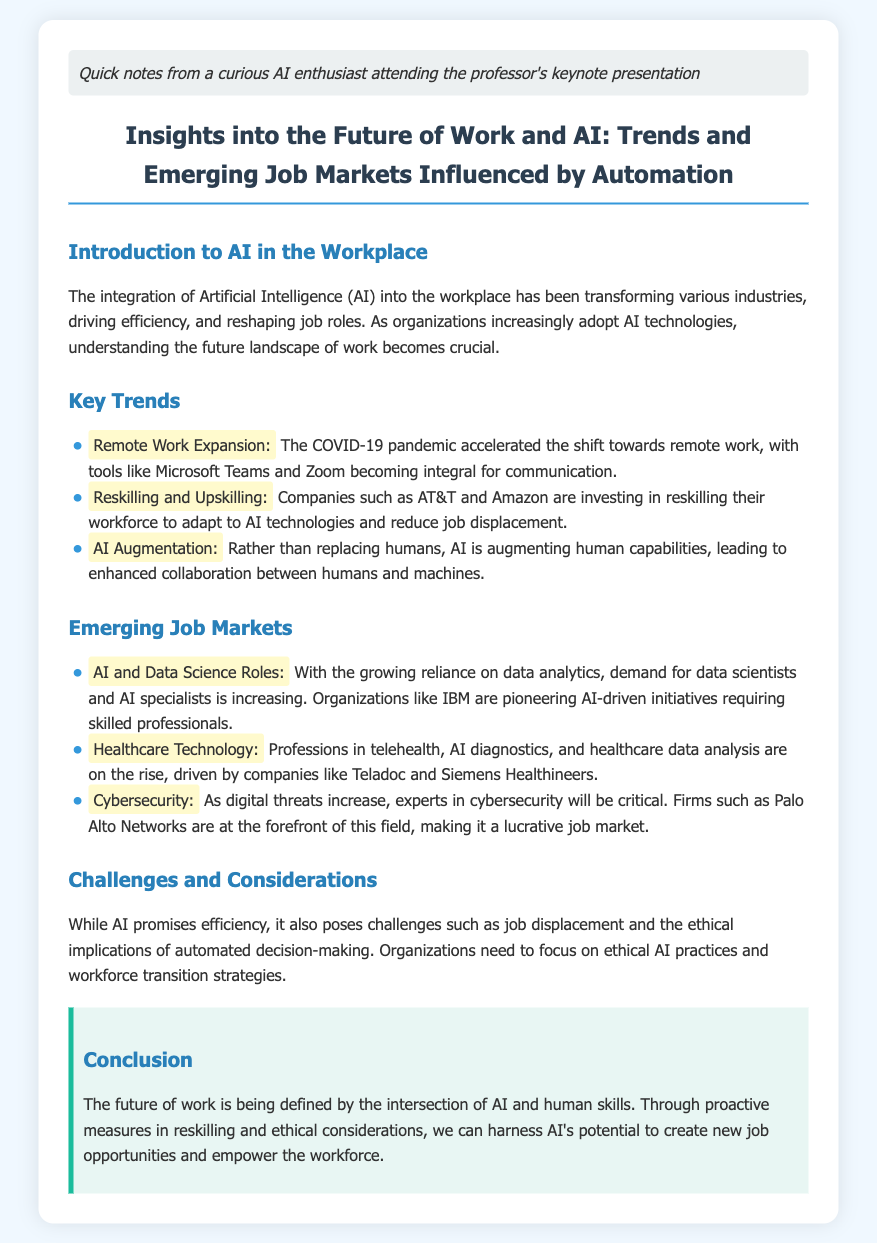What accelerated the shift towards remote work? The COVID-19 pandemic accelerated the shift towards remote work, as mentioned in the Key Trends section.
Answer: COVID-19 pandemic Which companies are investing in reskilling their workforce? Companies such as AT&T and Amazon are mentioned in the Key Trends section for investing in reskilling.
Answer: AT&T and Amazon What is the focus of emerging job markets in AI? The focus of emerging job markets is highlighted in the Emerging Job Markets section, particularly on AI and Data Science Roles.
Answer: AI and Data Science Roles What professions are rising in the healthcare technology field? The healthcare technology professions mentioned include telehealth, AI diagnostics, and healthcare data analysis.
Answer: Telehealth, AI diagnostics, and healthcare data analysis What challenges are associated with AI in the workplace? The challenges associated with AI in the workplace include job displacement and ethical implications of automated decision-making.
Answer: Job displacement and ethical implications In what area is Palo Alto Networks at the forefront? Palo Alto Networks is mentioned as being at the forefront of cybersecurity as indicated in the Emerging Job Markets section.
Answer: Cybersecurity What proactive measure can harness AI's potential? The document suggests that through proactive measures in reskilling, AI's potential can be harnessed for creating new job opportunities.
Answer: Reskilling What does AI promise according to the document? According to the document, AI promises efficiency within the workplace.
Answer: Efficiency What is a critical consideration for organizations adopting AI? A critical consideration for organizations adopting AI is to focus on ethical AI practices and workforce transition strategies.
Answer: Ethical AI practices and workforce transition strategies 